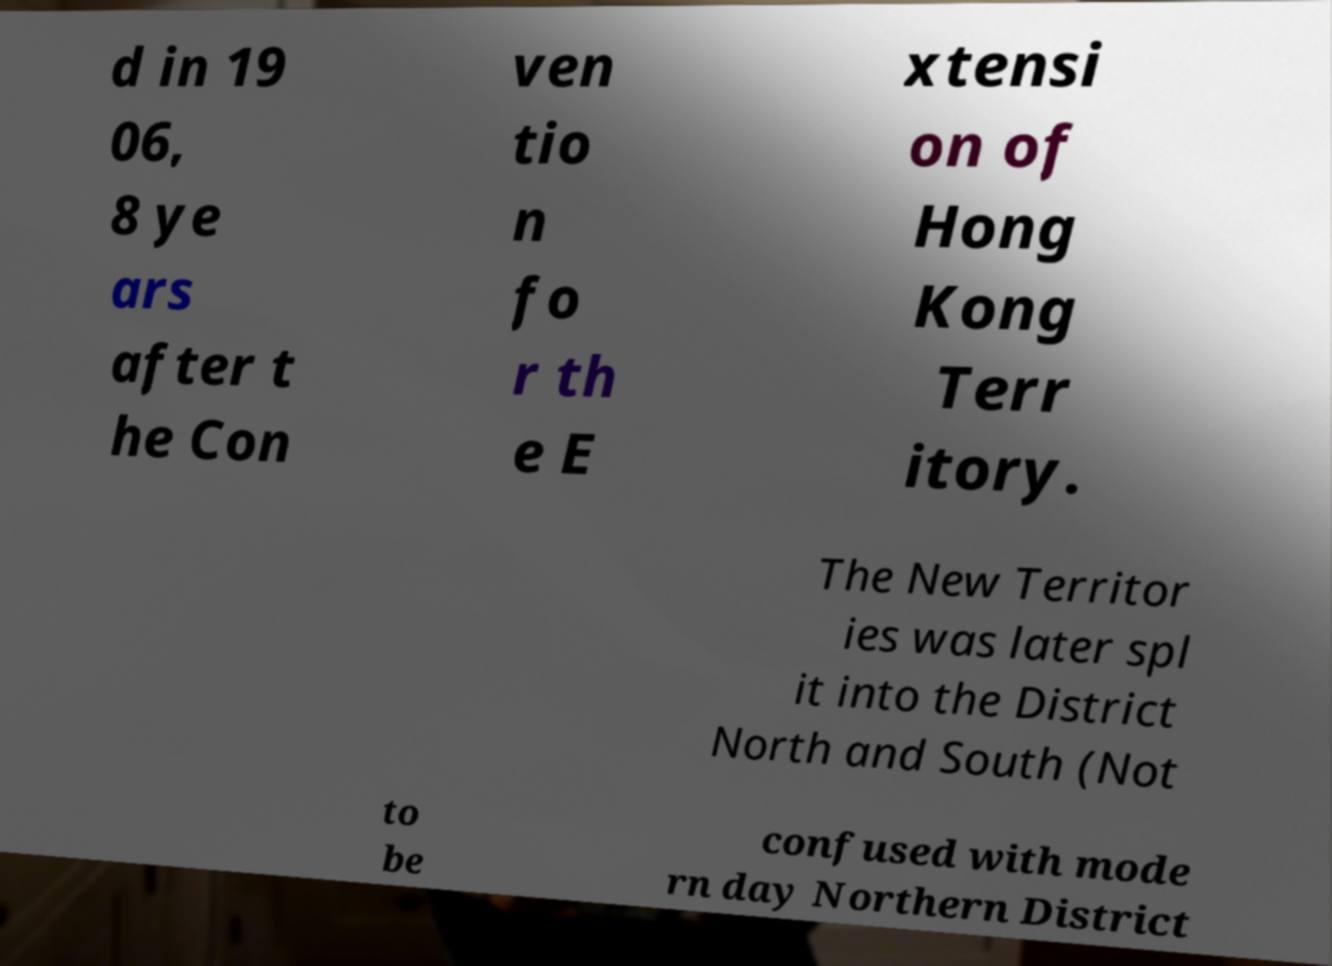Could you extract and type out the text from this image? d in 19 06, 8 ye ars after t he Con ven tio n fo r th e E xtensi on of Hong Kong Terr itory. The New Territor ies was later spl it into the District North and South (Not to be confused with mode rn day Northern District 